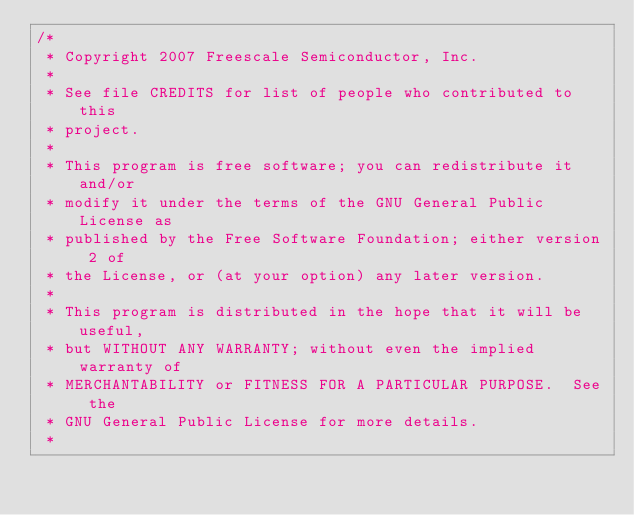Convert code to text. <code><loc_0><loc_0><loc_500><loc_500><_C_>/*
 * Copyright 2007 Freescale Semiconductor, Inc.
 *
 * See file CREDITS for list of people who contributed to this
 * project.
 *
 * This program is free software; you can redistribute it and/or
 * modify it under the terms of the GNU General Public License as
 * published by the Free Software Foundation; either version 2 of
 * the License, or (at your option) any later version.
 *
 * This program is distributed in the hope that it will be useful,
 * but WITHOUT ANY WARRANTY; without even the implied warranty of
 * MERCHANTABILITY or FITNESS FOR A PARTICULAR PURPOSE.  See the
 * GNU General Public License for more details.
 *</code> 